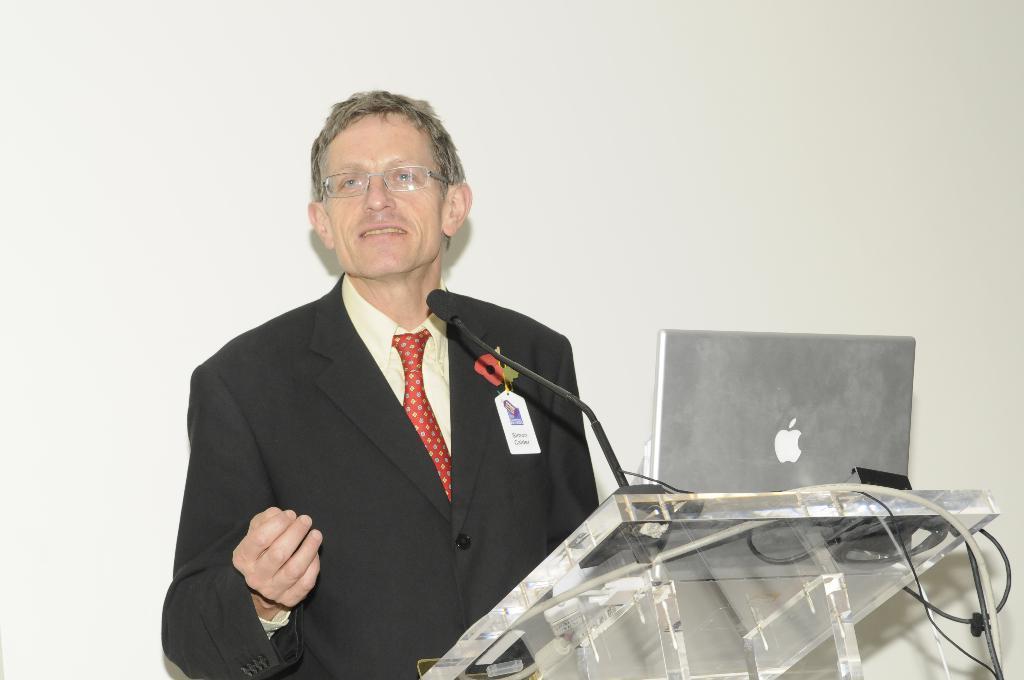Could you give a brief overview of what you see in this image? The person wearing suit is standing and there is a laptop and mic placed on a stand in front of him. 